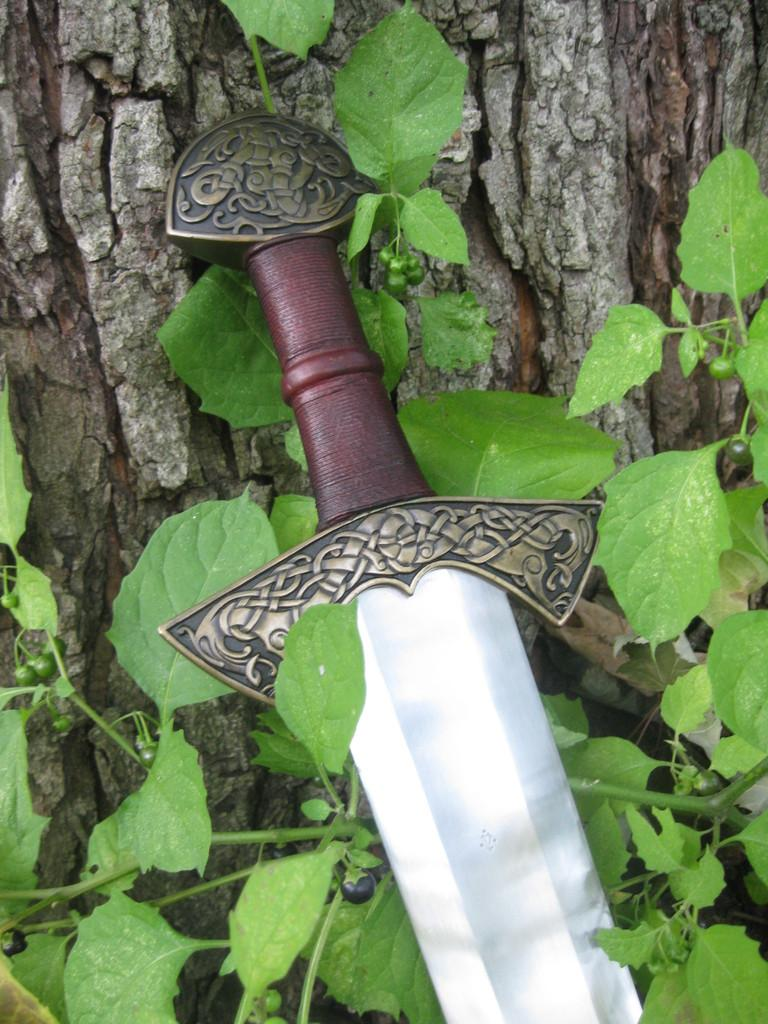What object can be seen in the image that is typically used as a weapon? There is a sword in the image. What type of natural element is present in the image? There is a tree in the image. What other types of vegetation can be seen in the image? There are plants in the image. What type of liquid is being twisted in the image? There is no liquid or twisting action present in the image. How does the wilderness affect the sword in the image? There is no wilderness present in the image, and therefore it cannot affect the sword. 